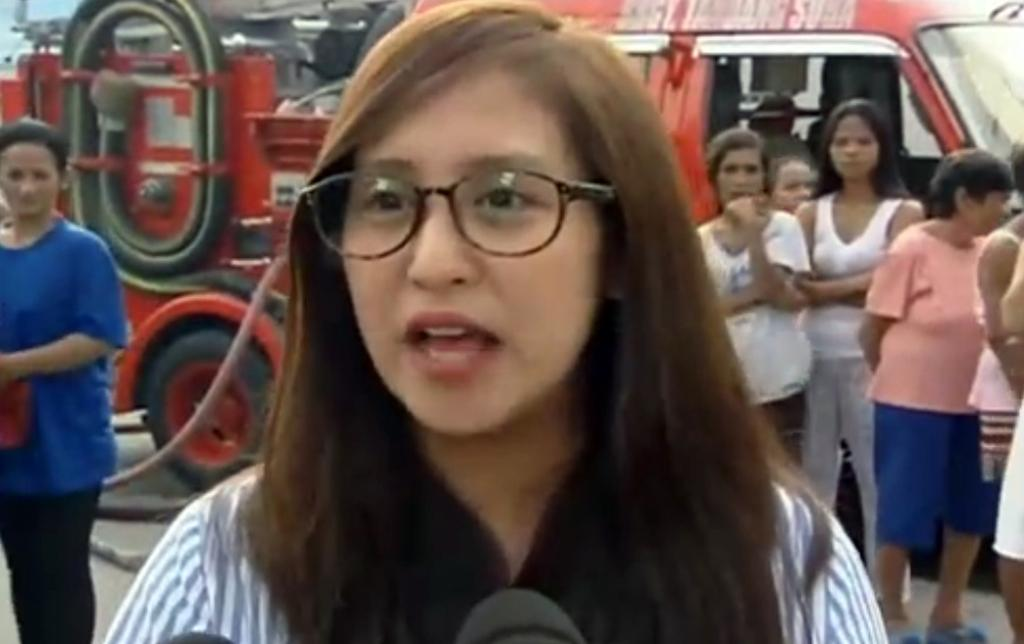What is the main subject in the foreground of the picture? There is a woman in the foreground of the picture. What is the woman doing in the picture? The woman is talking into a mic. What can be seen in the background of the picture? There are people standing in the background of the picture, and there is also a fire engine. What type of treatment is the woman receiving from the people in the background? There is no indication in the image that the woman is receiving any treatment from the people in the background. 